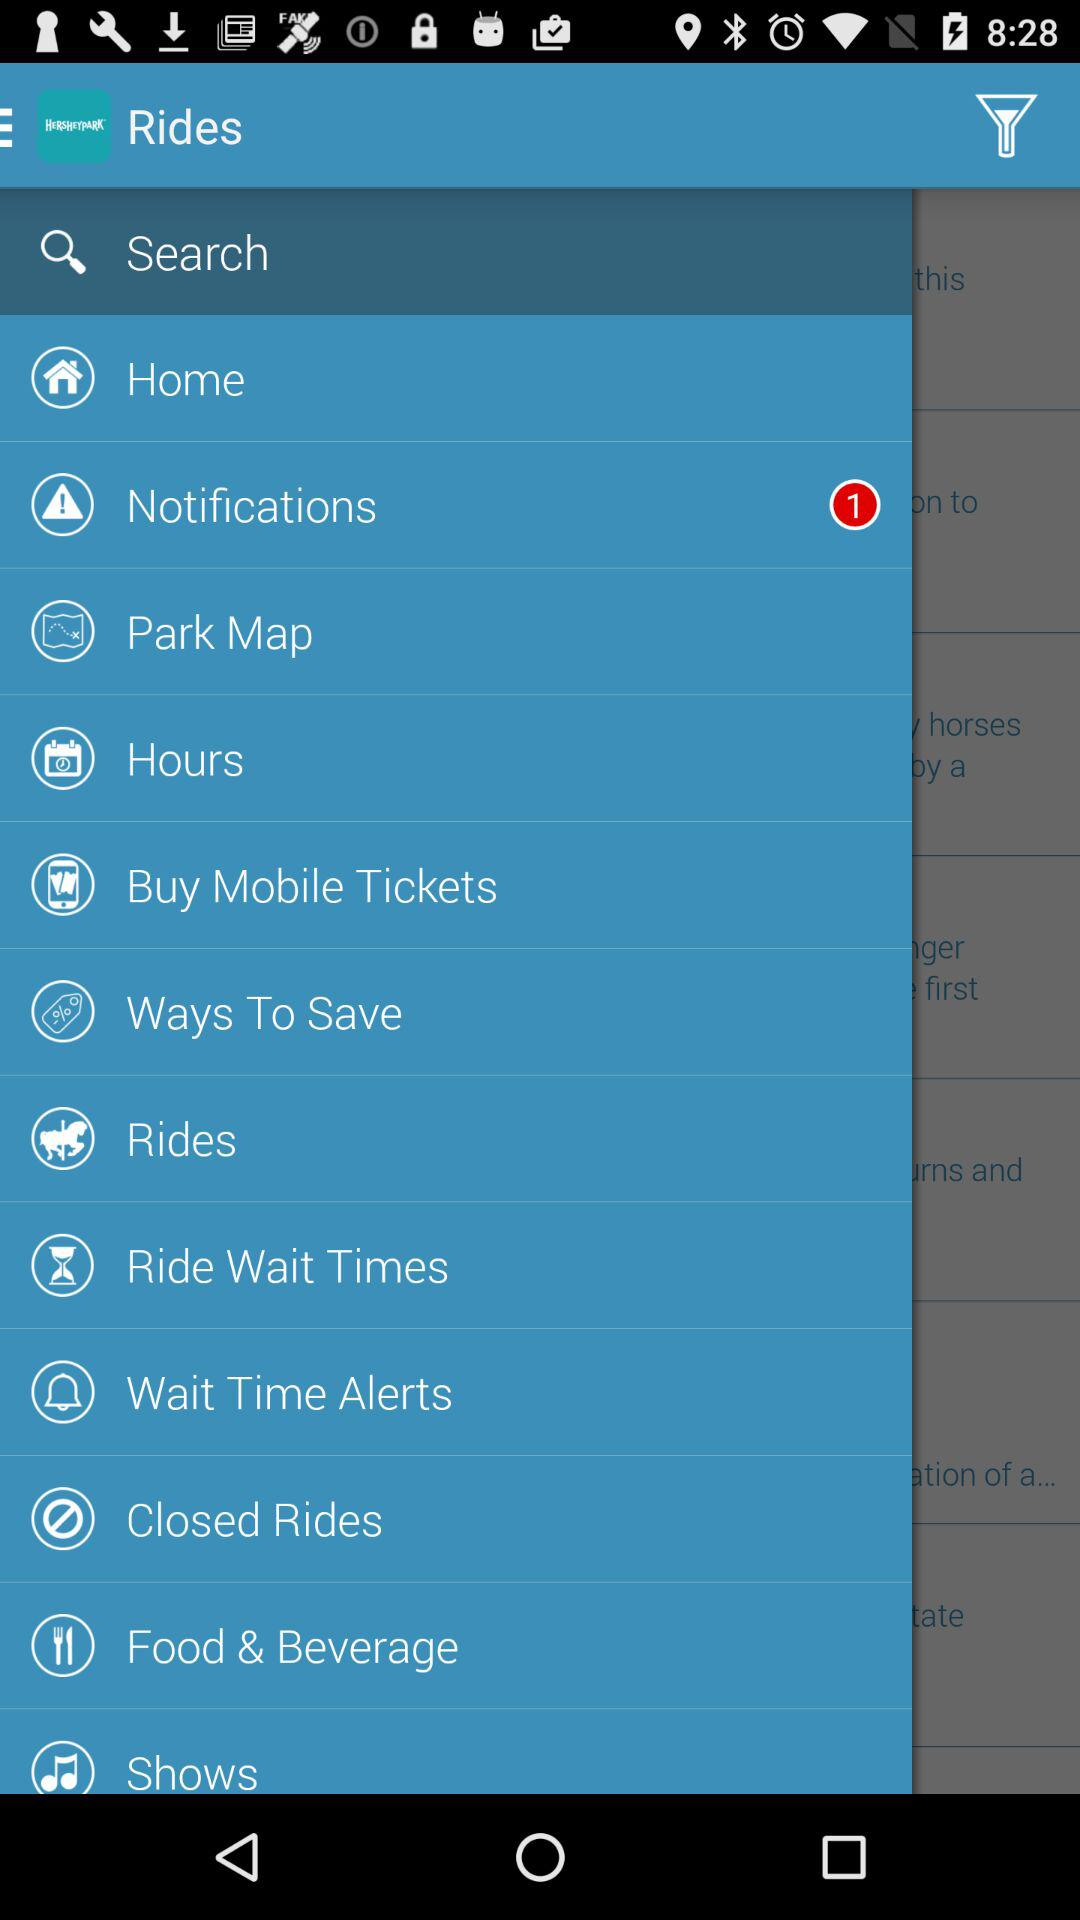Which item is selected? The selected item is "Search". 